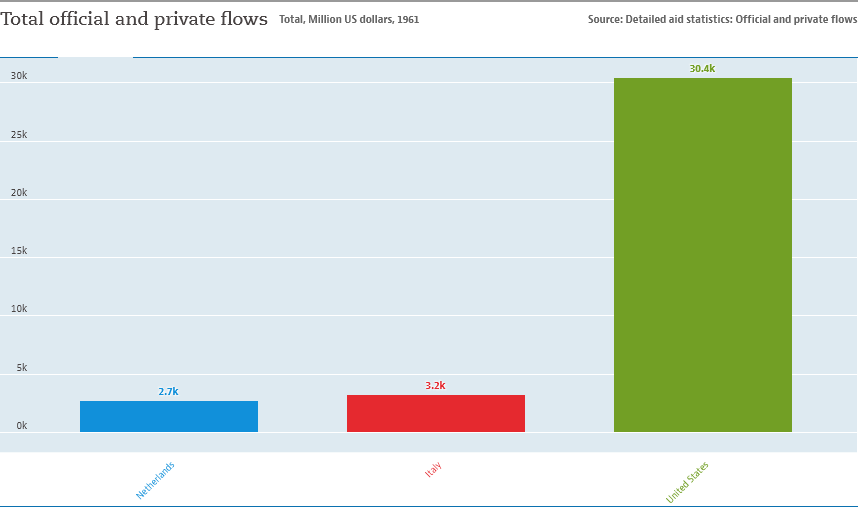List a handful of essential elements in this visual. The number of color bars in the graph is three. The sum of the Netherlands, Italy, and the United States is 36.3. 